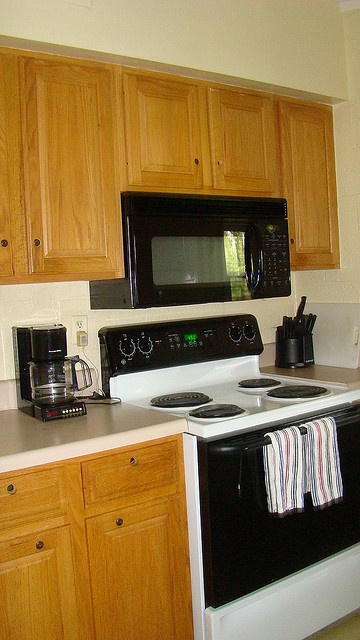Describe the objects in this image and their specific colors. I can see oven in tan, black, lightgray, darkgray, and gray tones, microwave in tan, black, gray, darkgreen, and olive tones, knife in tan, black, gray, and maroon tones, knife in tan, black, gray, and darkgreen tones, and knife in black and tan tones in this image. 